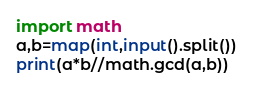<code> <loc_0><loc_0><loc_500><loc_500><_Python_>import math
a,b=map(int,input().split())
print(a*b//math.gcd(a,b))</code> 